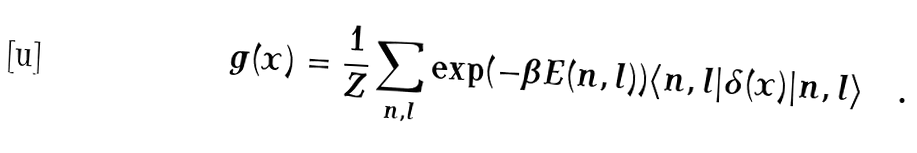<formula> <loc_0><loc_0><loc_500><loc_500>g ( x ) = \frac { 1 } { Z } \sum _ { n , l } \exp ( - \beta E ( n , l ) ) \langle n , l | \delta ( x ) | n , l \rangle \quad .</formula> 